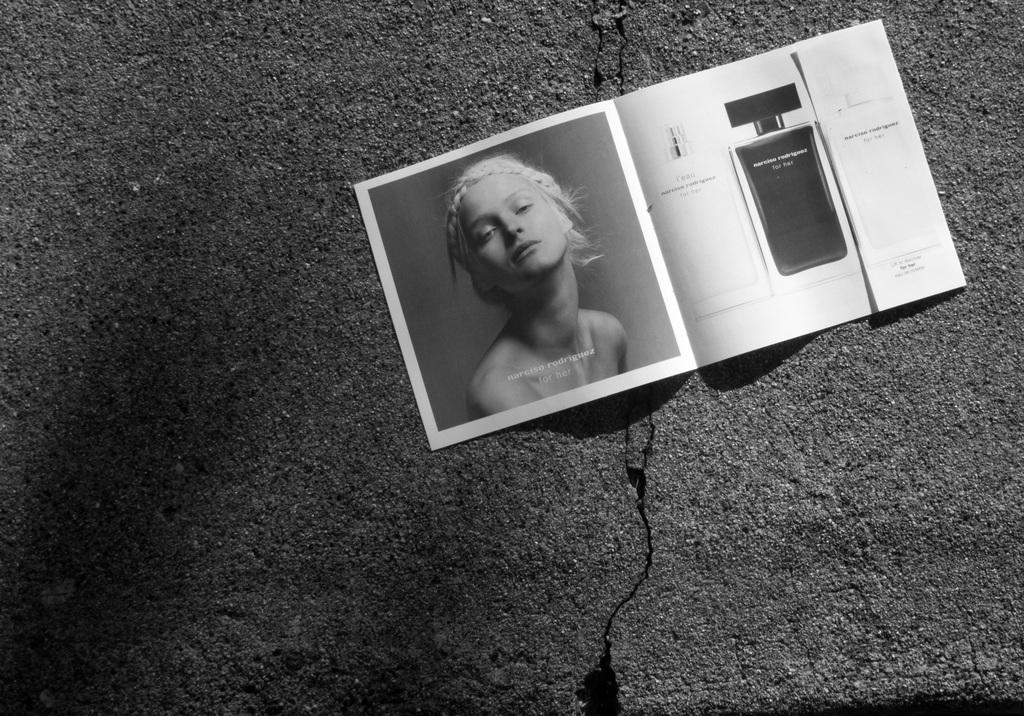How would you summarize this image in a sentence or two? I see this is a black and white image and I see the surface on which there is a paper over here on which there is a photo of a woman and I see few things over here. 